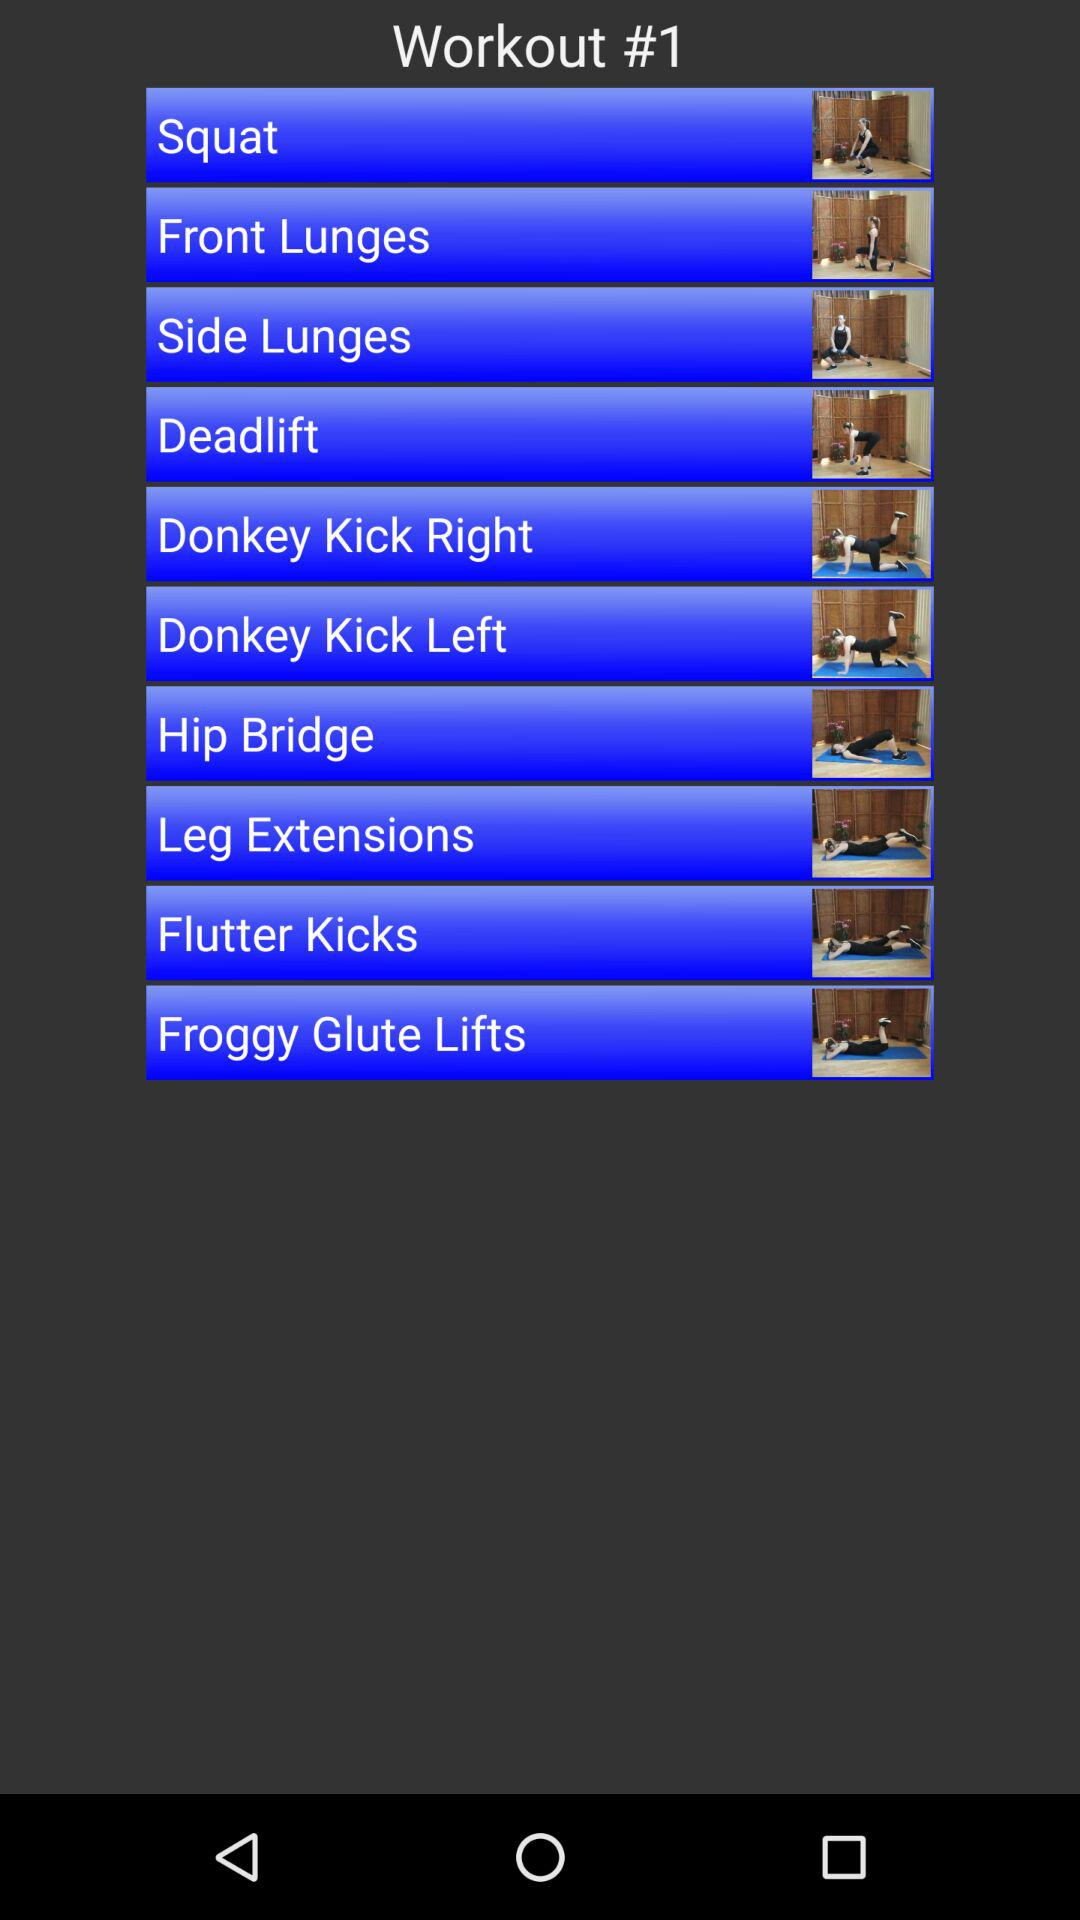What are the names of "Workout #1" day? The names are "Squat", "Front Lunges", "Side Lunges", "Deadlift", "Donkey Kick Right", "Donkey Kick Left", "Hip Bridge", "Leg Extensions", "Flutter Kicks", and "Froggy Glute Lifts". 